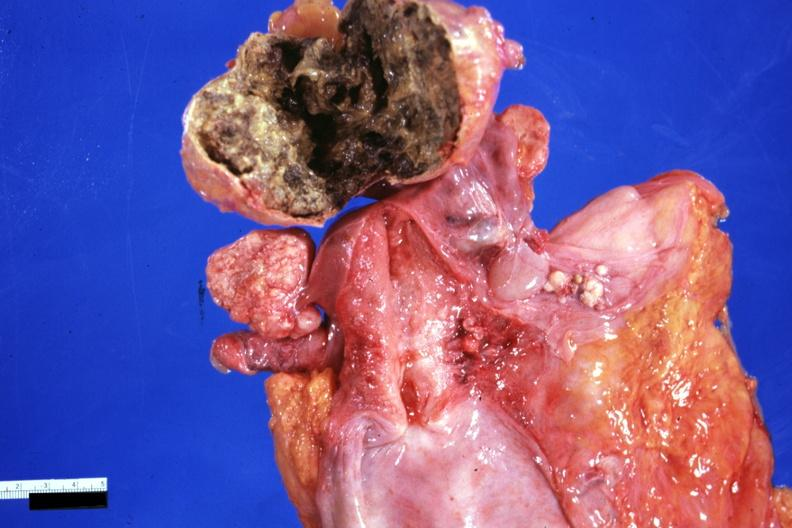what is present?
Answer the question using a single word or phrase. Benign cystic teratoma 